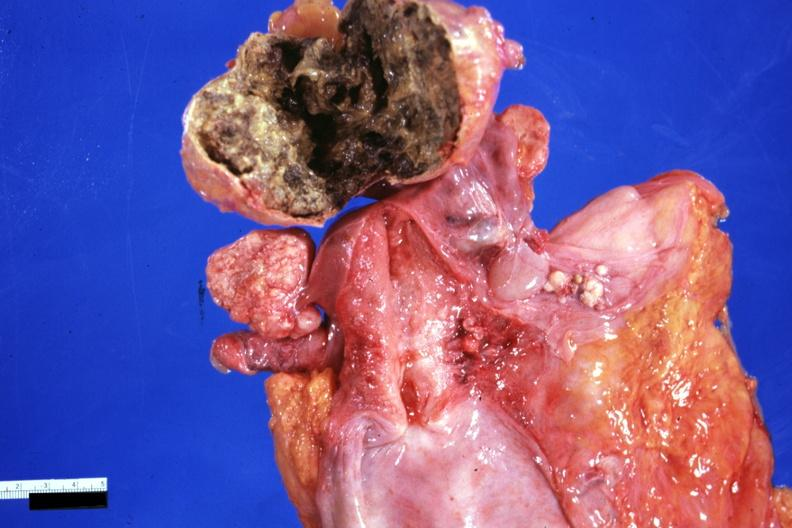what is present?
Answer the question using a single word or phrase. Benign cystic teratoma 